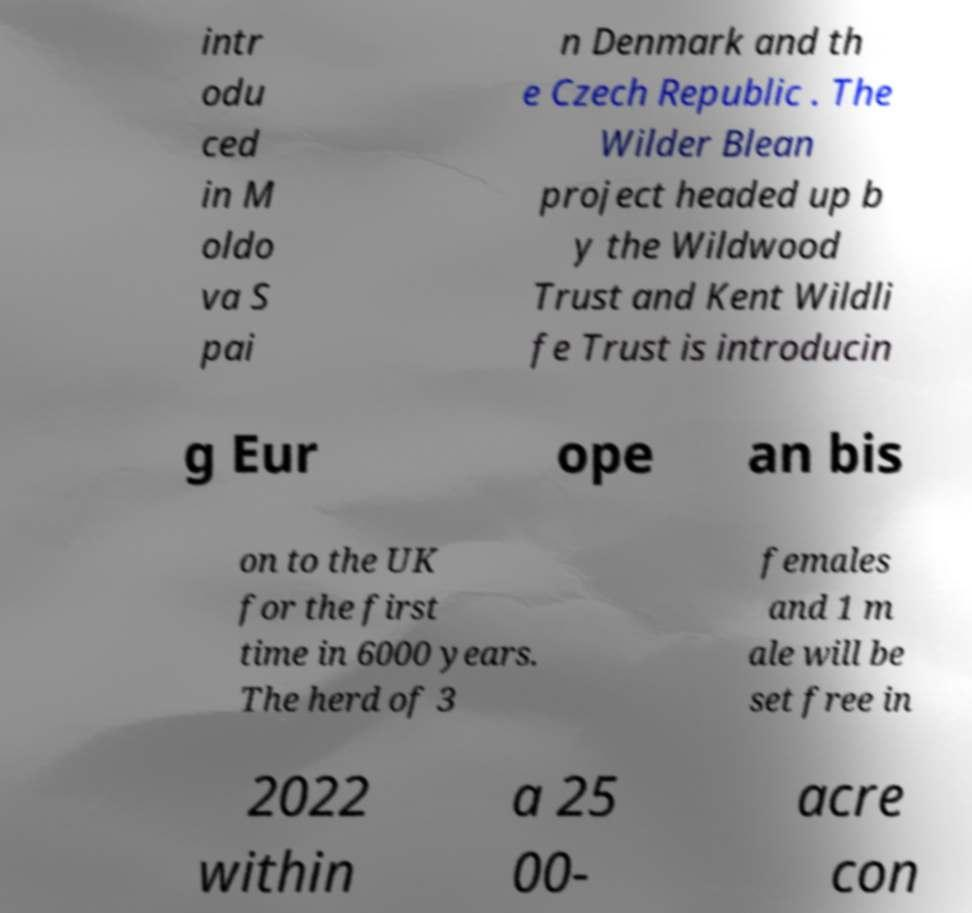For documentation purposes, I need the text within this image transcribed. Could you provide that? intr odu ced in M oldo va S pai n Denmark and th e Czech Republic . The Wilder Blean project headed up b y the Wildwood Trust and Kent Wildli fe Trust is introducin g Eur ope an bis on to the UK for the first time in 6000 years. The herd of 3 females and 1 m ale will be set free in 2022 within a 25 00- acre con 